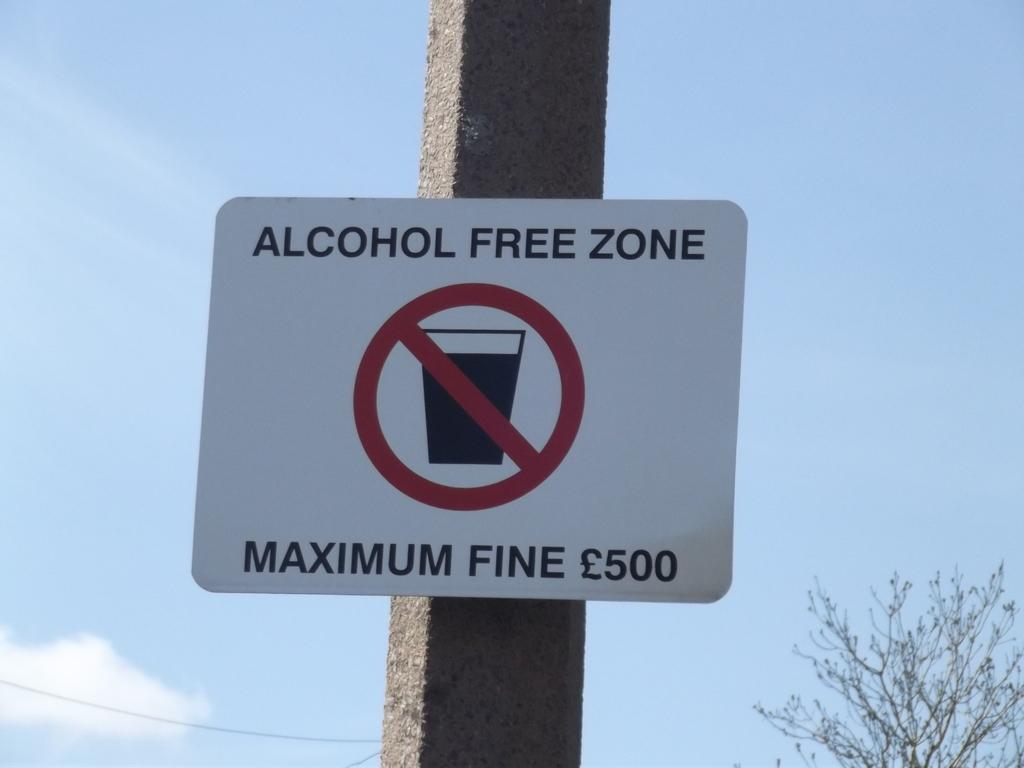<image>
Present a compact description of the photo's key features. A sign warningg that this is an alcohol free zone with a possible fine of 500 pounds. 